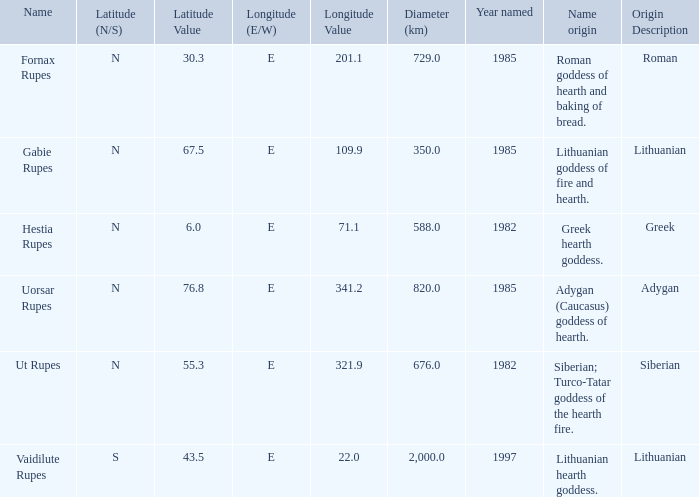At a latitude of 71.1e, what is the feature's name origin? Greek hearth goddess. 